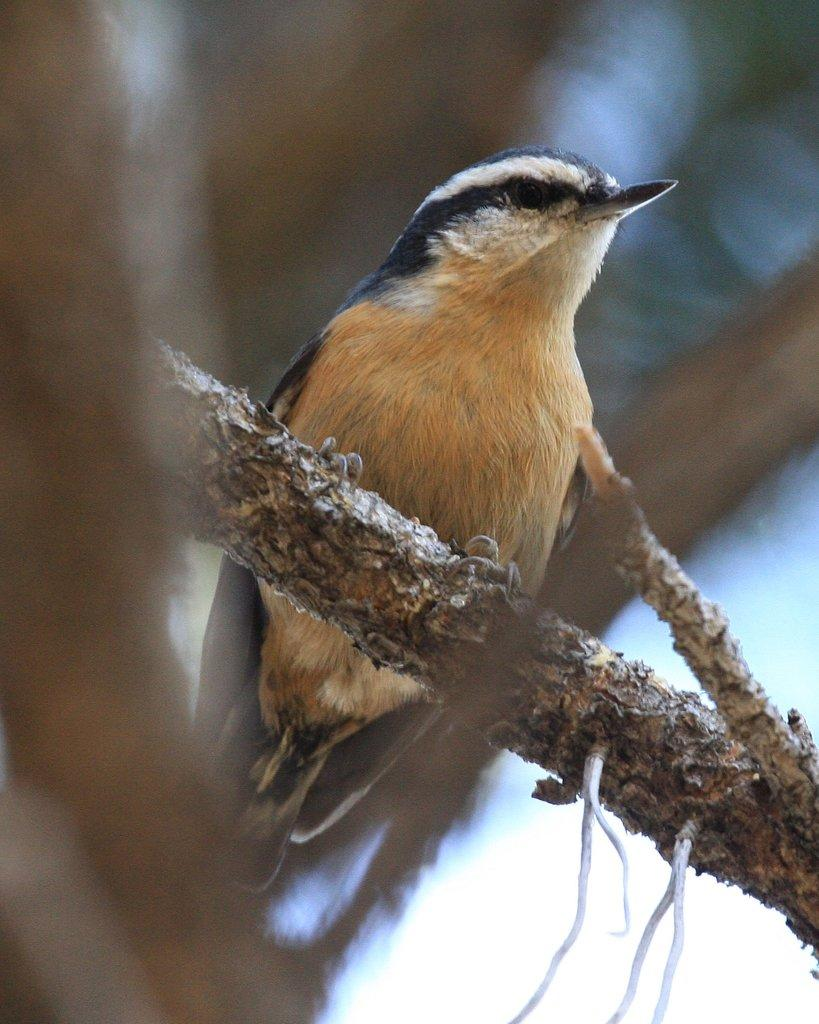What type of animal is in the image? There is a bird in the image. Where is the bird located in the image? The bird is on the branch of a tree. What can be seen in the background of the image? The sky is visible in the background of the image. What type of pie is the bird holding in its beak in the image? There is no pie present in the image; the bird is on the branch of a tree. Can you see any toys in the image? There are no toys present in the image. 